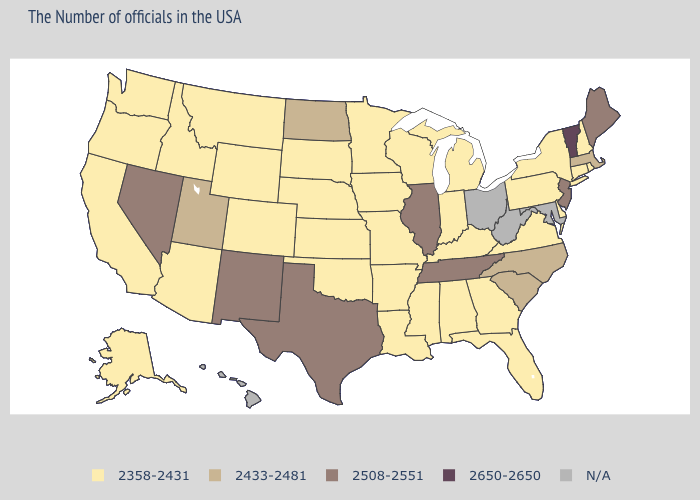Name the states that have a value in the range 2433-2481?
Quick response, please. Massachusetts, North Carolina, South Carolina, North Dakota, Utah. Does Tennessee have the highest value in the South?
Be succinct. Yes. What is the lowest value in the USA?
Answer briefly. 2358-2431. Does the map have missing data?
Write a very short answer. Yes. Which states have the lowest value in the West?
Short answer required. Wyoming, Colorado, Montana, Arizona, Idaho, California, Washington, Oregon, Alaska. Name the states that have a value in the range 2358-2431?
Give a very brief answer. Rhode Island, New Hampshire, Connecticut, New York, Delaware, Pennsylvania, Virginia, Florida, Georgia, Michigan, Kentucky, Indiana, Alabama, Wisconsin, Mississippi, Louisiana, Missouri, Arkansas, Minnesota, Iowa, Kansas, Nebraska, Oklahoma, South Dakota, Wyoming, Colorado, Montana, Arizona, Idaho, California, Washington, Oregon, Alaska. Name the states that have a value in the range N/A?
Give a very brief answer. Maryland, West Virginia, Ohio, Hawaii. Among the states that border Rhode Island , which have the lowest value?
Quick response, please. Connecticut. What is the value of New Hampshire?
Concise answer only. 2358-2431. Name the states that have a value in the range 2358-2431?
Answer briefly. Rhode Island, New Hampshire, Connecticut, New York, Delaware, Pennsylvania, Virginia, Florida, Georgia, Michigan, Kentucky, Indiana, Alabama, Wisconsin, Mississippi, Louisiana, Missouri, Arkansas, Minnesota, Iowa, Kansas, Nebraska, Oklahoma, South Dakota, Wyoming, Colorado, Montana, Arizona, Idaho, California, Washington, Oregon, Alaska. Does South Carolina have the highest value in the USA?
Keep it brief. No. Name the states that have a value in the range 2358-2431?
Give a very brief answer. Rhode Island, New Hampshire, Connecticut, New York, Delaware, Pennsylvania, Virginia, Florida, Georgia, Michigan, Kentucky, Indiana, Alabama, Wisconsin, Mississippi, Louisiana, Missouri, Arkansas, Minnesota, Iowa, Kansas, Nebraska, Oklahoma, South Dakota, Wyoming, Colorado, Montana, Arizona, Idaho, California, Washington, Oregon, Alaska. Name the states that have a value in the range 2650-2650?
Give a very brief answer. Vermont. Does the first symbol in the legend represent the smallest category?
Write a very short answer. Yes. 